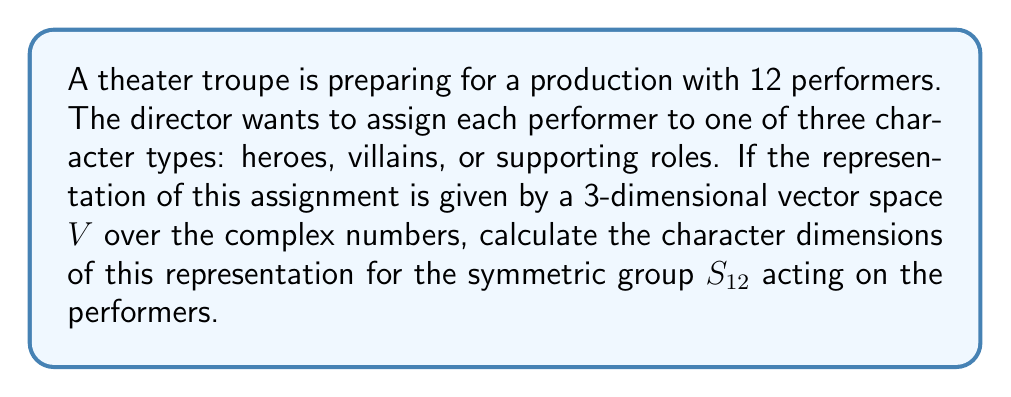Can you answer this question? To solve this problem, we'll follow these steps:

1) First, we need to understand what the representation is. In this case, it's a 3-dimensional vector space $V$ over $\mathbb{C}$, where each dimension corresponds to a character type (hero, villain, supporting role).

2) The symmetric group $S_{12}$ acts on this space by permuting the 12 performers.

3) The character of a representation is a function $\chi : S_{12} \to \mathbb{C}$ that assigns to each group element a complex number. For a permutation $\sigma \in S_{12}$, $\chi(\sigma)$ is the trace of the matrix representing $\sigma$ in this representation.

4) The character dimension is the value of $\chi(e)$, where $e$ is the identity element of $S_{12}$.

5) In this representation, the identity element $e$ fixes all performers, so it's represented by the 3x3 identity matrix:

   $$\begin{pmatrix}
   1 & 0 & 0 \\
   0 & 1 & 0 \\
   0 & 0 & 1
   \end{pmatrix}$$

6) The trace of this matrix (sum of diagonal elements) is 3.

Therefore, the character dimension of this representation is 3.
Answer: 3 